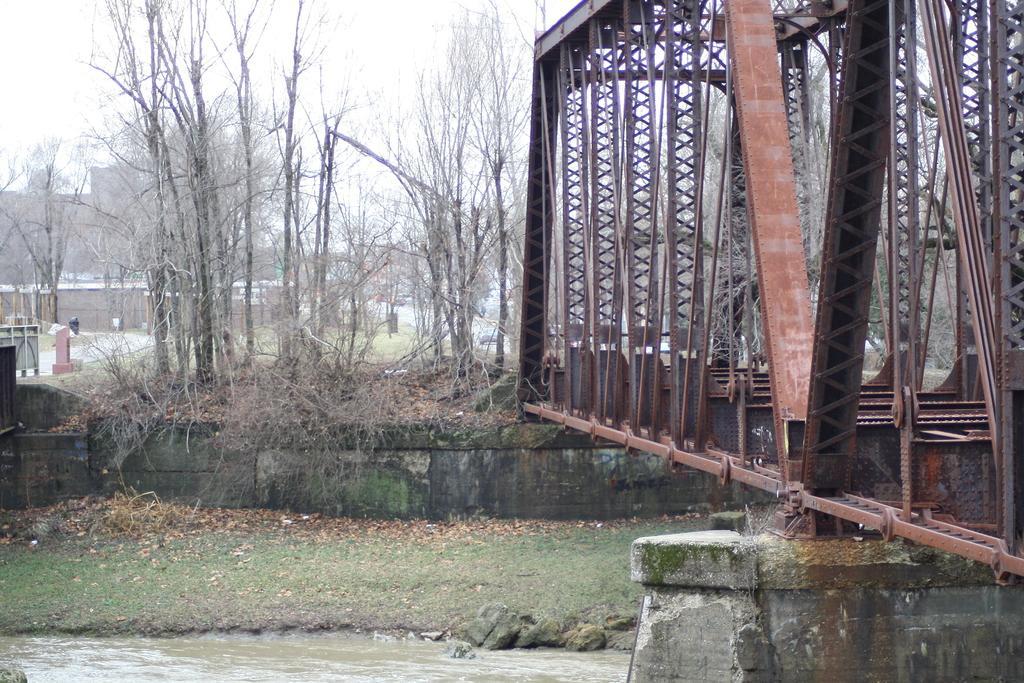How would you summarize this image in a sentence or two? In this image I can see few dry trees, buildings, bridge, water and few dry leaves. The sky is in white color. 